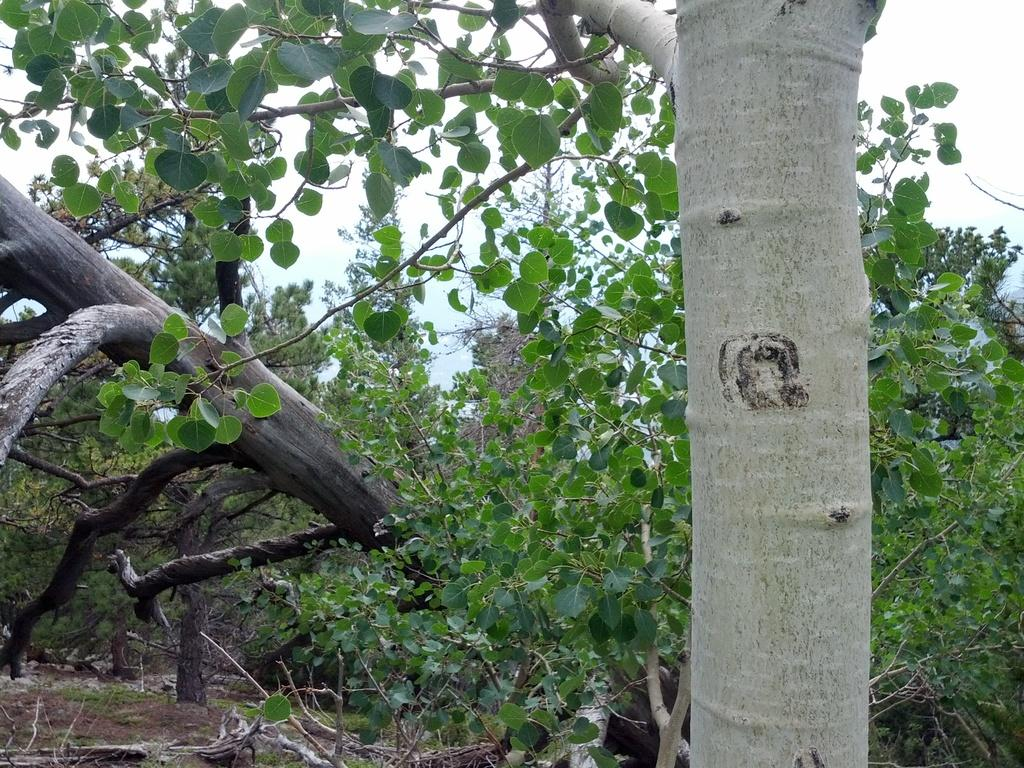What type of vegetation is present in the image? The image contains trees. What else can be seen on the ground in the image? There are wooden logs in the image. What is the ground made of in the image? Soil is present in the image. What can be seen in the background of the image? The sky is visible in the background of the image. What part of a tree is visible in the foreground of the image? The trunk of a tree is visible in the foreground of the image. What type of smoke can be seen coming from the tree in the image? There is no smoke present in the image; it features trees, wooden logs, soil, and a visible sky. 